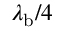<formula> <loc_0><loc_0><loc_500><loc_500>\lambda _ { b } / 4</formula> 